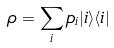<formula> <loc_0><loc_0><loc_500><loc_500>\rho = \sum _ { i } p _ { i } | i \rangle \langle i |</formula> 